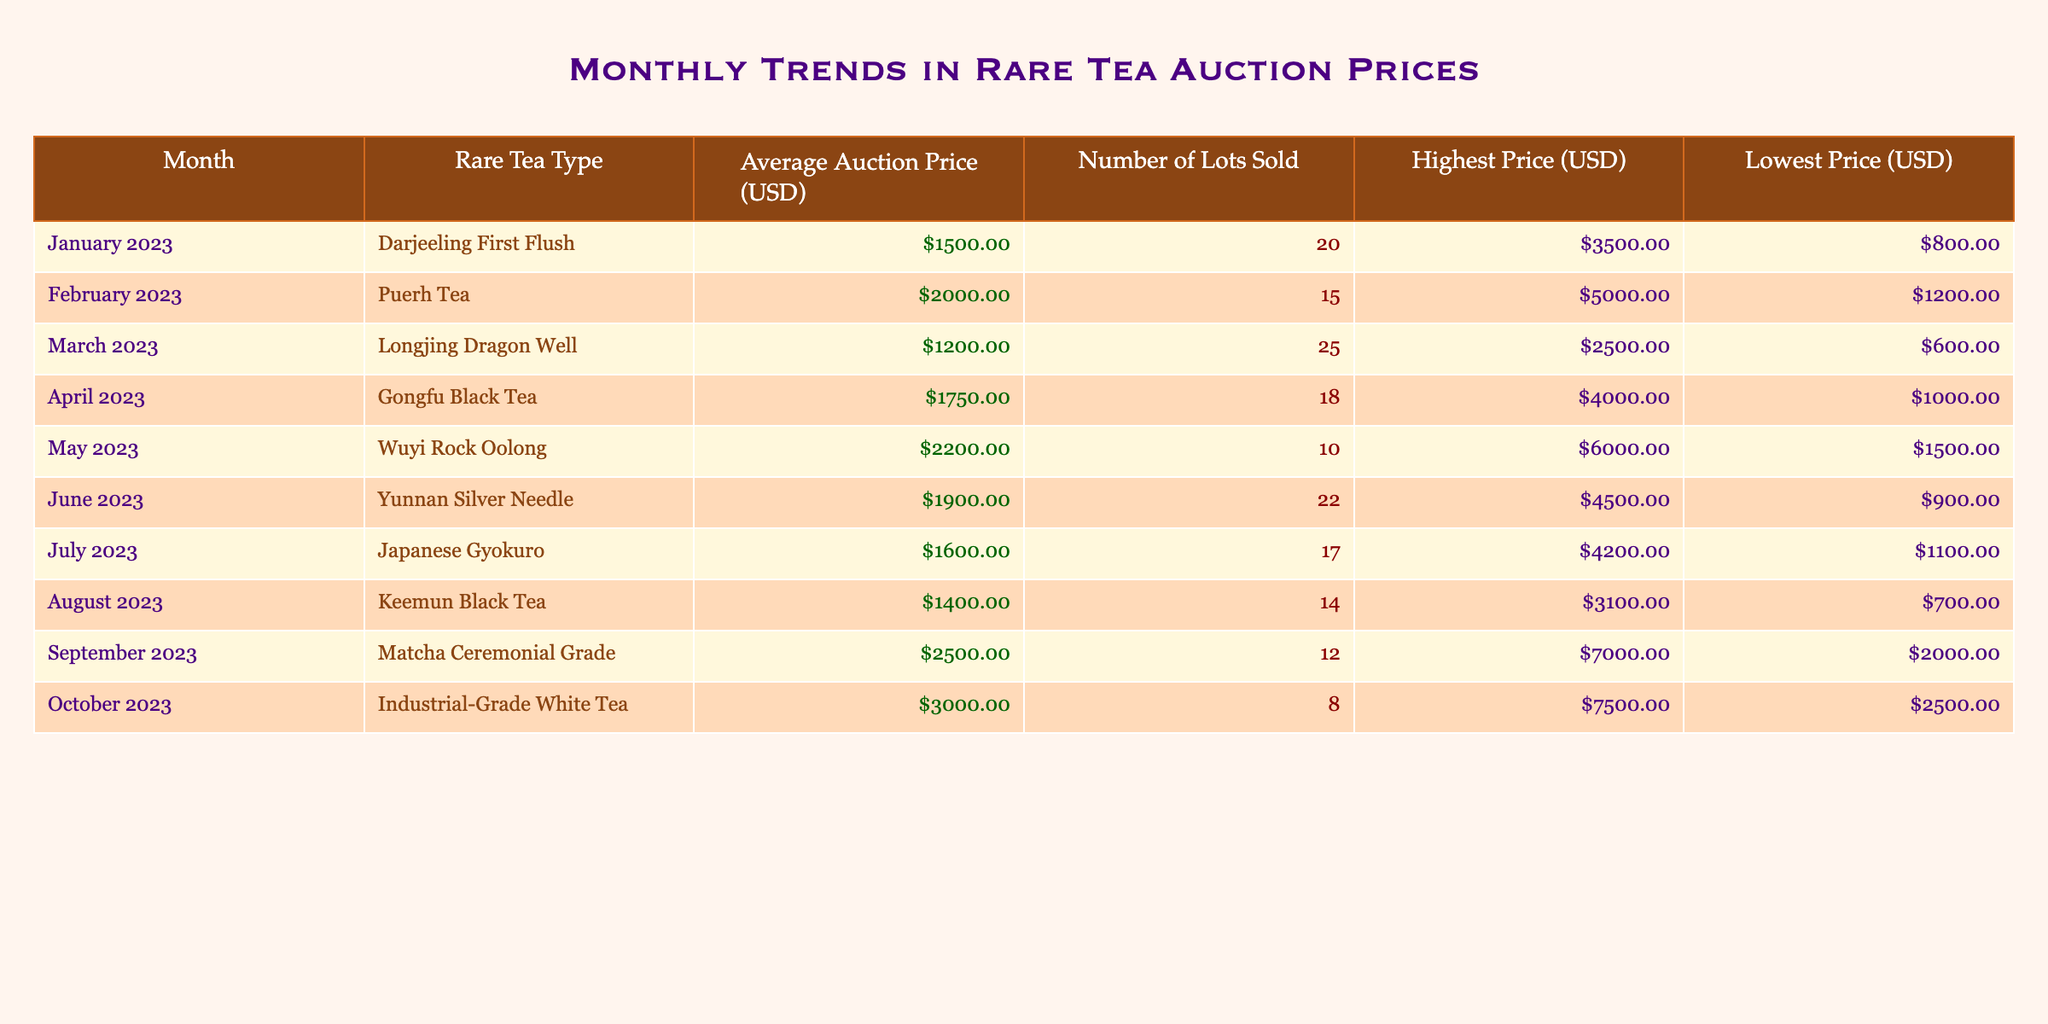What was the highest auction price for Puerh Tea? The table indicates that the highest auction price for Puerh Tea in February 2023 is $5000.
Answer: $5000 Which month saw the lowest average auction price? By comparing the average auction prices listed for each month, August 2023 has the lowest average auction price of $1400.
Answer: August 2023 What is the total number of lots sold for Wuyi Rock Oolong and Japanese Gyokuro combined? The number of lots sold for Wuyi Rock Oolong is 10, and for Japanese Gyokuro, it is 17. Adding these together gives 10 + 17 = 27 lots sold combined.
Answer: 27 Is it true that the average auction price for Industrial-Grade White Tea in October is higher than that for Matcha Ceremonial Grade in September? Yes, the average auction price for Industrial-Grade White Tea in October is $3000, which is higher than Matcha Ceremonial Grade's average price of $2500 in September.
Answer: Yes What was the difference in the highest auction prices between May 2023 (Wuyi Rock Oolong) and April 2023 (Gongfu Black Tea)? The highest price for Wuyi Rock Oolong is $6000, and for Gongfu Black Tea, it is $4000. The difference is $6000 - $4000 = $2000.
Answer: $2000 What is the average auction price for Darjeeling First Flush and Longjing Dragon Well? The average for Darjeeling First Flush is $1500, and for Longjing Dragon Well, it is $1200. Adding them gives $1500 + $1200 = $2700, and then dividing by 2 gives an average of $2700 / 2 = $1350.
Answer: $1350 Which rare tea type had the second highest average auction price this year? By comparing all average auction prices, the second highest is Wuyi Rock Oolong at $2200, following Industrial-Grade White Tea which had the highest price of $3000.
Answer: Wuyi Rock Oolong In which month did the least number of lots sold occur? The table shows that the least number of lots sold occurred in October 2023, where only 8 lots were sold for Industrial-Grade White Tea.
Answer: October 2023 Calculate the average auction price for the three tea types sold in June, July, and August. The average auction prices for these months are $1900 (June), $1600 (July), and $1400 (August). Adding these values gives $1900 + $1600 + $1400 = $4900, and then dividing by 3 gives $4900 / 3 = approximately $1633.33.
Answer: $1633.33 Did the auction prices for rare teas increase on average from January to October 2023? To ascertain this, we check the average auction prices month by month. January ($1500), February ($2000), March ($1200), April ($1750), May ($2200), June ($1900), July ($1600), August ($1400), September ($2500), and October ($3000). Overall, the trend shows an increase in average prices from January to October with variations in certain months.
Answer: Yes What was the average lowest price across all rare tea types sold during the year? The lowest prices for each month are: $800 (January), $1200 (February), $600 (March), $1000 (April), $1500 (May), $900 (June), $1100 (July), $700 (August), $2000 (September), and $2500 (October). The total is $800 + $1200 + $600 + $1000 + $1500 + $900 + $1100 + $700 + $2000 + $2500 = $10500. Dividing this by 10 gives an average of $1050.
Answer: $1050 